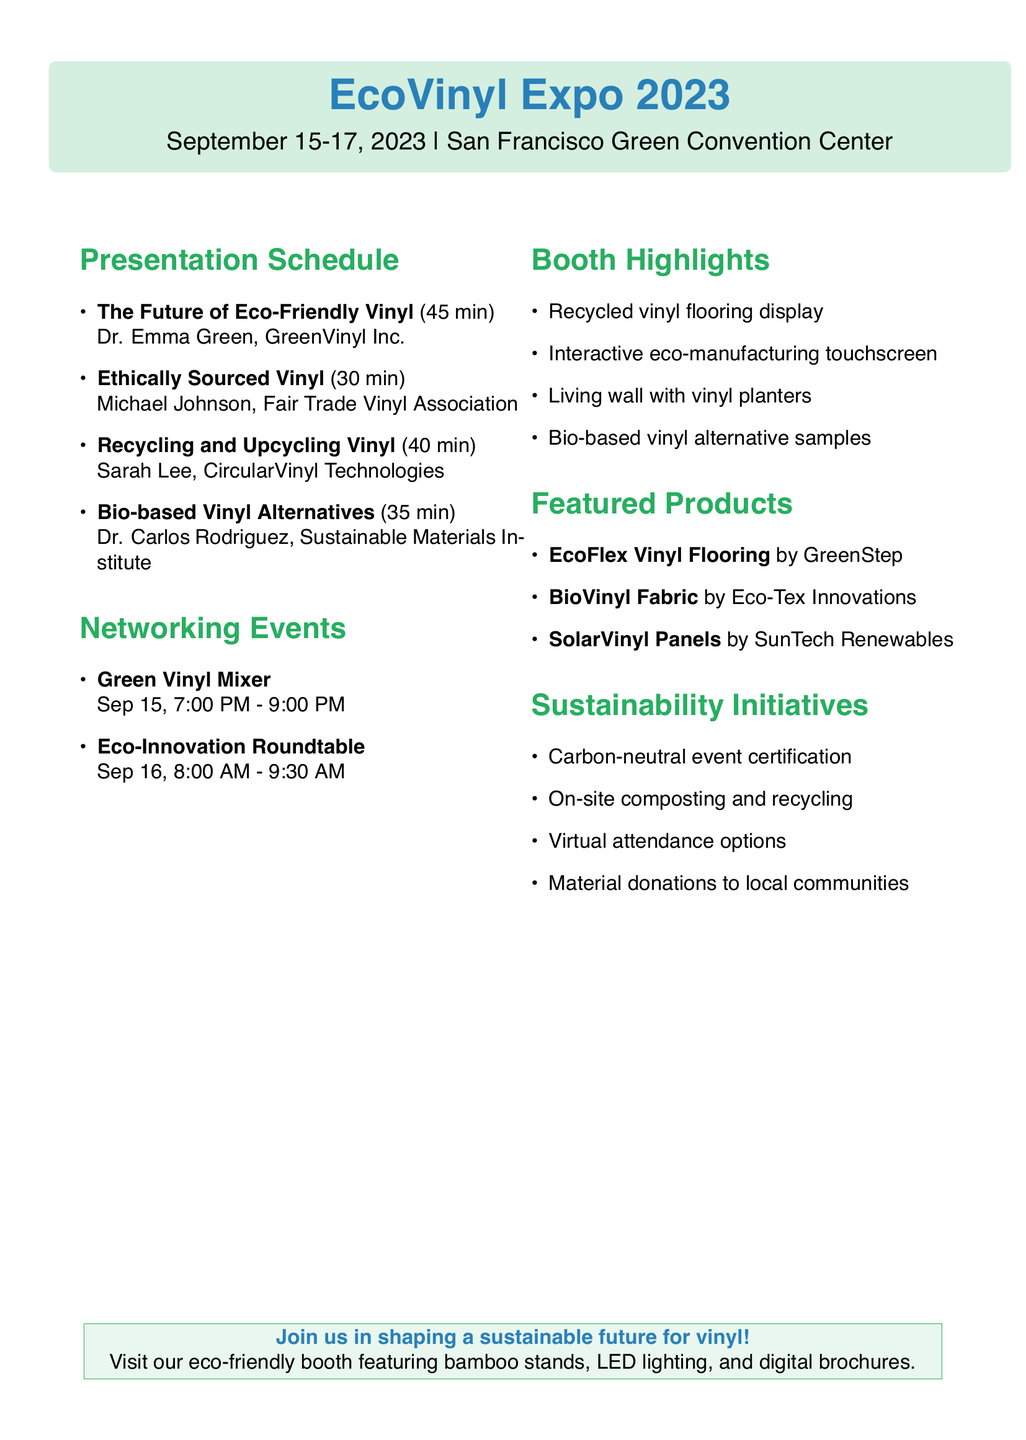What is the location of EcoVinyl Expo 2023? The location is specified in the document as San Francisco Green Convention Center.
Answer: San Francisco Green Convention Center Who is the speaker for the topic "Ethically Sourced Vinyl"? This information can be found in the presentation topics section, indicating who is speaking on this subject.
Answer: Michael Johnson What is the duration of the presentation titled "Recycling and Upcycling Vinyl"? The duration is included in the presentation schedule and indicates how long the presentation will last.
Answer: 40 minutes What is one of the sustainability initiatives mentioned in the document? The document lists several initiatives, requiring retrieval of one instance that emphasizes sustainability.
Answer: Carbon-neutral event certification When does the Green Vinyl Mixer event take place? This is detailed in the networking events section, providing the date and time for this specific gathering.
Answer: September 15, 2023, 7:00 PM - 9:00 PM Identify a product showcased at the expo. This question requires reviewing the product showcases section for any example products listed.
Answer: EcoFlex Vinyl Flooring What theme is represented in the booth design? The theme is mentioned directly in the booth design section and reflects the overall concept of the display.
Answer: Sustainable Vinyl Solutions Which material is used for the display stands in the booth design? The specific material for the display stands is detailed in the booth design section, prompting a quick retrieval of the answer.
Answer: Bamboo display stands 